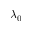<formula> <loc_0><loc_0><loc_500><loc_500>\lambda _ { 0 }</formula> 